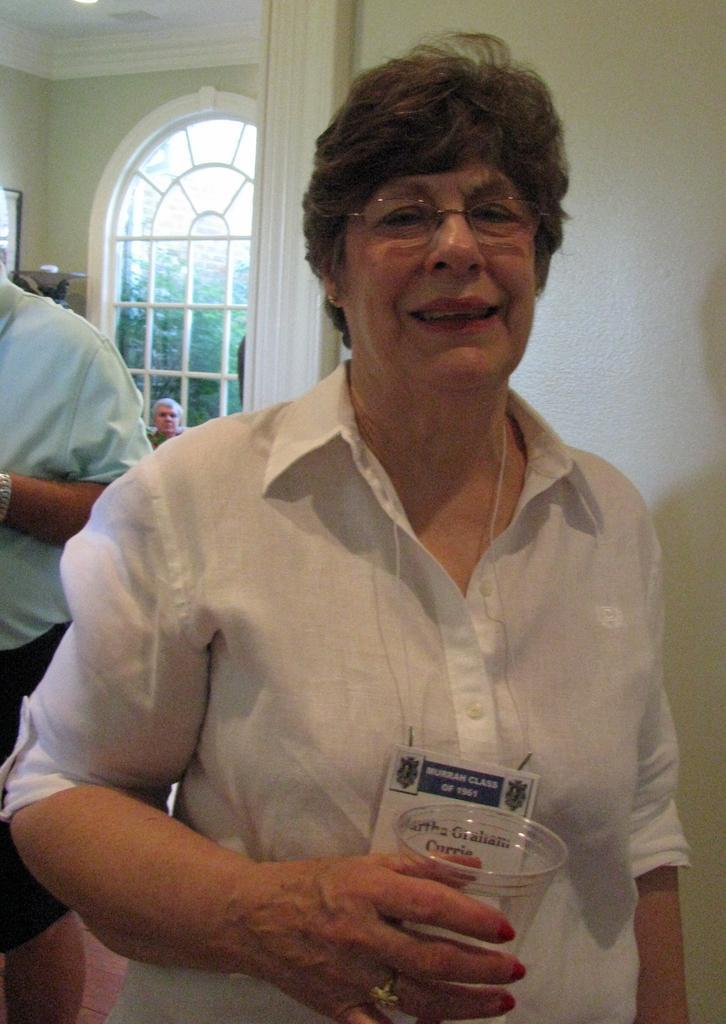Describe this image in one or two sentences. This picture describes about group of people, in the middle of the image we can see a woman, she wore spectacles and she is holding a glass, in the background we can see few trees. 